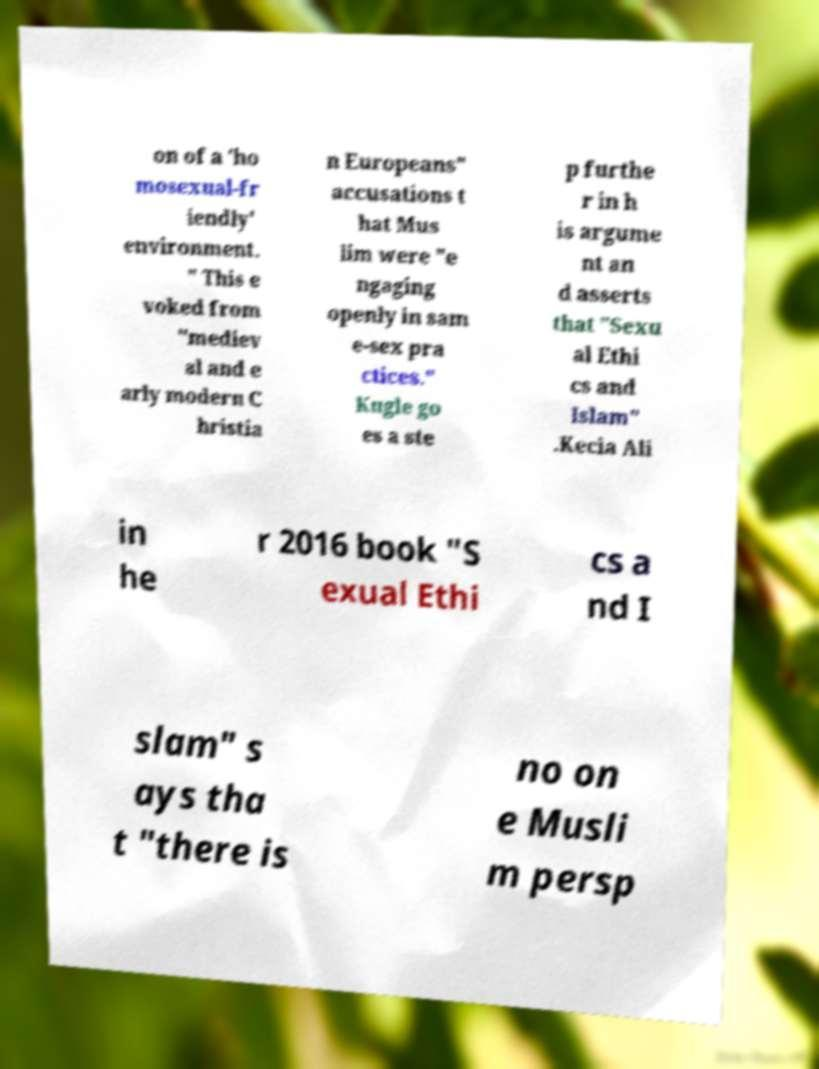There's text embedded in this image that I need extracted. Can you transcribe it verbatim? on of a 'ho mosexual-fr iendly' environment. " This e voked from "mediev al and e arly modern C hristia n Europeans" accusations t hat Mus lim were "e ngaging openly in sam e-sex pra ctices." Kugle go es a ste p furthe r in h is argume nt an d asserts that "Sexu al Ethi cs and Islam" .Kecia Ali in he r 2016 book "S exual Ethi cs a nd I slam" s ays tha t "there is no on e Musli m persp 